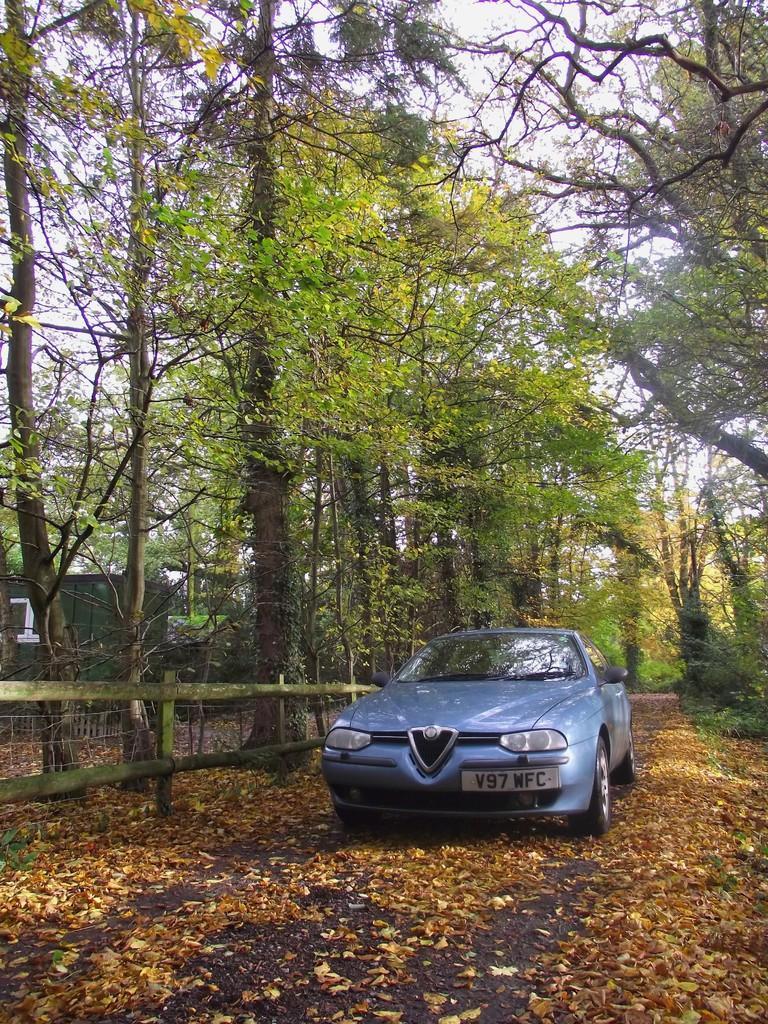Could you give a brief overview of what you see in this image? In this image in the front there are dry leaves on the ground. In the center there is a car and there is a fence. In the background there are trees. On the left side there is an object which is white in colour and there is a curtain which is green in colour. 